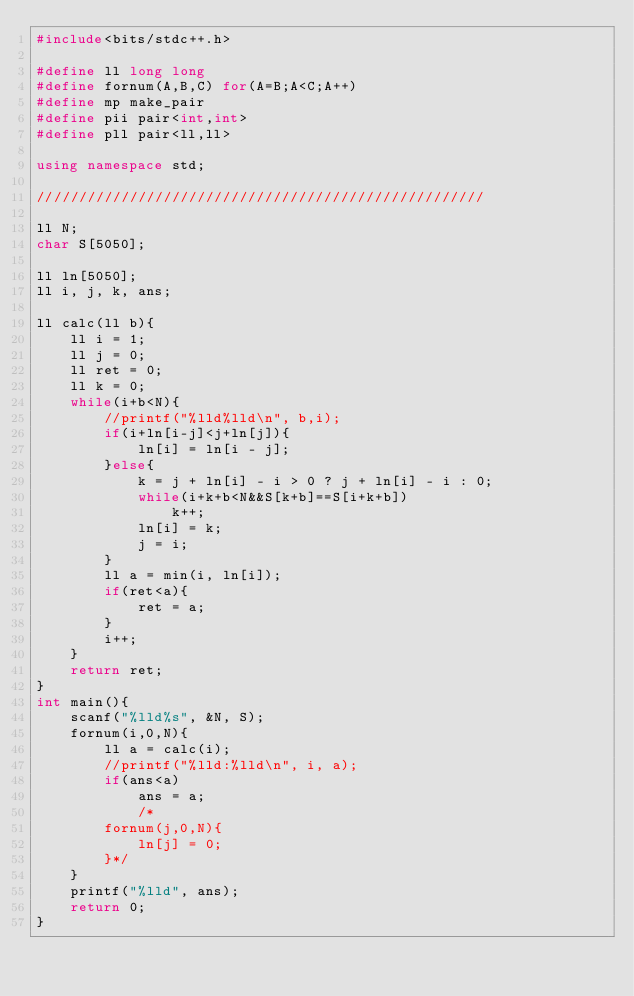<code> <loc_0><loc_0><loc_500><loc_500><_C++_>#include<bits/stdc++.h>

#define ll long long
#define fornum(A,B,C) for(A=B;A<C;A++)
#define mp make_pair
#define pii pair<int,int>
#define pll pair<ll,ll>

using namespace std;

/////////////////////////////////////////////////////

ll N;
char S[5050];

ll ln[5050];
ll i, j, k, ans;

ll calc(ll b){
    ll i = 1;
    ll j = 0;
    ll ret = 0;
    ll k = 0;
    while(i+b<N){
        //printf("%lld%lld\n", b,i);
        if(i+ln[i-j]<j+ln[j]){
            ln[i] = ln[i - j];
        }else{
            k = j + ln[i] - i > 0 ? j + ln[i] - i : 0;
            while(i+k+b<N&&S[k+b]==S[i+k+b])
                k++;
            ln[i] = k;
            j = i;
        }
        ll a = min(i, ln[i]);
        if(ret<a){
            ret = a;
        }
        i++;
    }
    return ret;
}
int main(){
    scanf("%lld%s", &N, S);
    fornum(i,0,N){
        ll a = calc(i);
        //printf("%lld:%lld\n", i, a);
        if(ans<a)
            ans = a;
            /*
        fornum(j,0,N){
            ln[j] = 0;
        }*/
    }
    printf("%lld", ans);
    return 0;
}</code> 